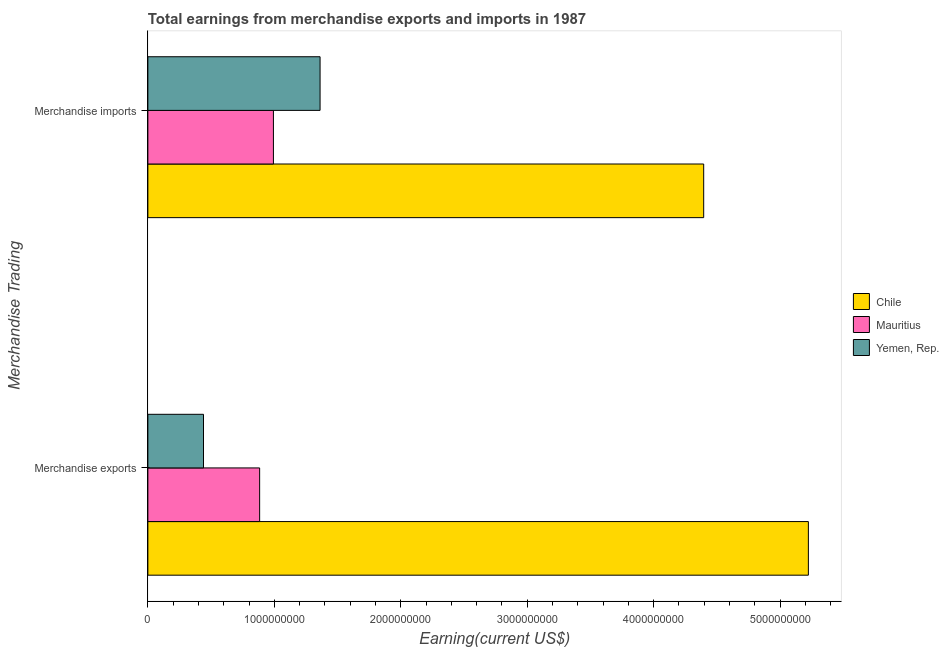How many different coloured bars are there?
Offer a terse response. 3. How many groups of bars are there?
Ensure brevity in your answer.  2. Are the number of bars on each tick of the Y-axis equal?
Ensure brevity in your answer.  Yes. How many bars are there on the 2nd tick from the top?
Offer a terse response. 3. How many bars are there on the 1st tick from the bottom?
Offer a very short reply. 3. What is the label of the 1st group of bars from the top?
Provide a short and direct response. Merchandise imports. What is the earnings from merchandise exports in Yemen, Rep.?
Your answer should be very brief. 4.40e+08. Across all countries, what is the maximum earnings from merchandise exports?
Provide a succinct answer. 5.22e+09. Across all countries, what is the minimum earnings from merchandise exports?
Your answer should be compact. 4.40e+08. In which country was the earnings from merchandise exports maximum?
Provide a short and direct response. Chile. In which country was the earnings from merchandise exports minimum?
Ensure brevity in your answer.  Yemen, Rep. What is the total earnings from merchandise imports in the graph?
Make the answer very short. 6.75e+09. What is the difference between the earnings from merchandise exports in Chile and that in Mauritius?
Your response must be concise. 4.34e+09. What is the difference between the earnings from merchandise imports in Mauritius and the earnings from merchandise exports in Yemen, Rep.?
Give a very brief answer. 5.53e+08. What is the average earnings from merchandise imports per country?
Provide a short and direct response. 2.25e+09. What is the difference between the earnings from merchandise imports and earnings from merchandise exports in Chile?
Provide a succinct answer. -8.28e+08. What is the ratio of the earnings from merchandise exports in Mauritius to that in Yemen, Rep.?
Give a very brief answer. 2.01. In how many countries, is the earnings from merchandise exports greater than the average earnings from merchandise exports taken over all countries?
Offer a very short reply. 1. What does the 2nd bar from the top in Merchandise imports represents?
Give a very brief answer. Mauritius. What does the 3rd bar from the bottom in Merchandise imports represents?
Your answer should be compact. Yemen, Rep. Does the graph contain any zero values?
Keep it short and to the point. No. Where does the legend appear in the graph?
Offer a terse response. Center right. How many legend labels are there?
Your answer should be very brief. 3. What is the title of the graph?
Keep it short and to the point. Total earnings from merchandise exports and imports in 1987. What is the label or title of the X-axis?
Provide a succinct answer. Earning(current US$). What is the label or title of the Y-axis?
Keep it short and to the point. Merchandise Trading. What is the Earning(current US$) of Chile in Merchandise exports?
Ensure brevity in your answer.  5.22e+09. What is the Earning(current US$) of Mauritius in Merchandise exports?
Your response must be concise. 8.84e+08. What is the Earning(current US$) of Yemen, Rep. in Merchandise exports?
Give a very brief answer. 4.40e+08. What is the Earning(current US$) of Chile in Merchandise imports?
Your response must be concise. 4.40e+09. What is the Earning(current US$) in Mauritius in Merchandise imports?
Offer a terse response. 9.93e+08. What is the Earning(current US$) of Yemen, Rep. in Merchandise imports?
Keep it short and to the point. 1.36e+09. Across all Merchandise Trading, what is the maximum Earning(current US$) in Chile?
Keep it short and to the point. 5.22e+09. Across all Merchandise Trading, what is the maximum Earning(current US$) of Mauritius?
Make the answer very short. 9.93e+08. Across all Merchandise Trading, what is the maximum Earning(current US$) of Yemen, Rep.?
Give a very brief answer. 1.36e+09. Across all Merchandise Trading, what is the minimum Earning(current US$) in Chile?
Give a very brief answer. 4.40e+09. Across all Merchandise Trading, what is the minimum Earning(current US$) of Mauritius?
Keep it short and to the point. 8.84e+08. Across all Merchandise Trading, what is the minimum Earning(current US$) of Yemen, Rep.?
Keep it short and to the point. 4.40e+08. What is the total Earning(current US$) in Chile in the graph?
Keep it short and to the point. 9.62e+09. What is the total Earning(current US$) of Mauritius in the graph?
Provide a short and direct response. 1.88e+09. What is the total Earning(current US$) in Yemen, Rep. in the graph?
Your response must be concise. 1.80e+09. What is the difference between the Earning(current US$) of Chile in Merchandise exports and that in Merchandise imports?
Your answer should be compact. 8.28e+08. What is the difference between the Earning(current US$) in Mauritius in Merchandise exports and that in Merchandise imports?
Offer a terse response. -1.09e+08. What is the difference between the Earning(current US$) of Yemen, Rep. in Merchandise exports and that in Merchandise imports?
Make the answer very short. -9.22e+08. What is the difference between the Earning(current US$) of Chile in Merchandise exports and the Earning(current US$) of Mauritius in Merchandise imports?
Provide a short and direct response. 4.23e+09. What is the difference between the Earning(current US$) of Chile in Merchandise exports and the Earning(current US$) of Yemen, Rep. in Merchandise imports?
Your answer should be compact. 3.86e+09. What is the difference between the Earning(current US$) of Mauritius in Merchandise exports and the Earning(current US$) of Yemen, Rep. in Merchandise imports?
Give a very brief answer. -4.78e+08. What is the average Earning(current US$) in Chile per Merchandise Trading?
Provide a short and direct response. 4.81e+09. What is the average Earning(current US$) of Mauritius per Merchandise Trading?
Your response must be concise. 9.38e+08. What is the average Earning(current US$) of Yemen, Rep. per Merchandise Trading?
Make the answer very short. 9.01e+08. What is the difference between the Earning(current US$) in Chile and Earning(current US$) in Mauritius in Merchandise exports?
Make the answer very short. 4.34e+09. What is the difference between the Earning(current US$) in Chile and Earning(current US$) in Yemen, Rep. in Merchandise exports?
Make the answer very short. 4.78e+09. What is the difference between the Earning(current US$) in Mauritius and Earning(current US$) in Yemen, Rep. in Merchandise exports?
Your response must be concise. 4.44e+08. What is the difference between the Earning(current US$) of Chile and Earning(current US$) of Mauritius in Merchandise imports?
Your answer should be compact. 3.40e+09. What is the difference between the Earning(current US$) of Chile and Earning(current US$) of Yemen, Rep. in Merchandise imports?
Provide a short and direct response. 3.03e+09. What is the difference between the Earning(current US$) in Mauritius and Earning(current US$) in Yemen, Rep. in Merchandise imports?
Your answer should be very brief. -3.69e+08. What is the ratio of the Earning(current US$) in Chile in Merchandise exports to that in Merchandise imports?
Give a very brief answer. 1.19. What is the ratio of the Earning(current US$) of Mauritius in Merchandise exports to that in Merchandise imports?
Your answer should be compact. 0.89. What is the ratio of the Earning(current US$) in Yemen, Rep. in Merchandise exports to that in Merchandise imports?
Keep it short and to the point. 0.32. What is the difference between the highest and the second highest Earning(current US$) of Chile?
Provide a short and direct response. 8.28e+08. What is the difference between the highest and the second highest Earning(current US$) of Mauritius?
Offer a very short reply. 1.09e+08. What is the difference between the highest and the second highest Earning(current US$) in Yemen, Rep.?
Give a very brief answer. 9.22e+08. What is the difference between the highest and the lowest Earning(current US$) of Chile?
Provide a succinct answer. 8.28e+08. What is the difference between the highest and the lowest Earning(current US$) of Mauritius?
Ensure brevity in your answer.  1.09e+08. What is the difference between the highest and the lowest Earning(current US$) of Yemen, Rep.?
Offer a terse response. 9.22e+08. 